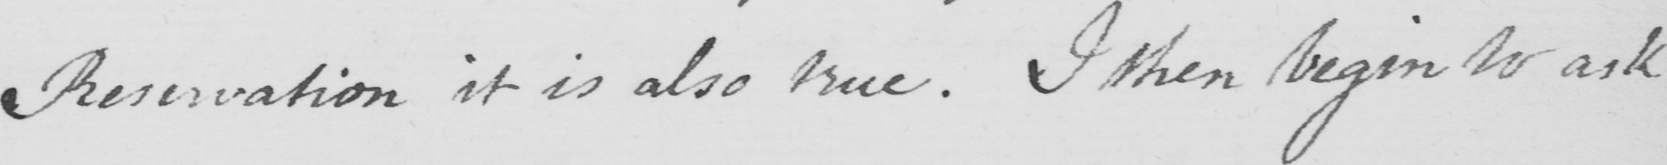What does this handwritten line say? Reservation it is also true . I then begin to ask 